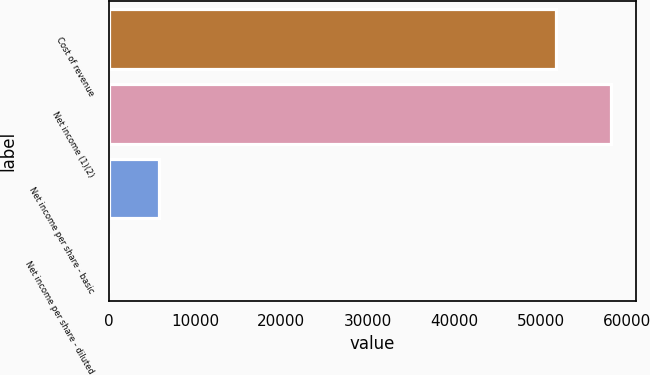Convert chart to OTSL. <chart><loc_0><loc_0><loc_500><loc_500><bar_chart><fcel>Cost of revenue<fcel>Net income (1)(2)<fcel>Net income per share - basic<fcel>Net income per share - diluted<nl><fcel>51755<fcel>58160<fcel>5816.17<fcel>0.19<nl></chart> 